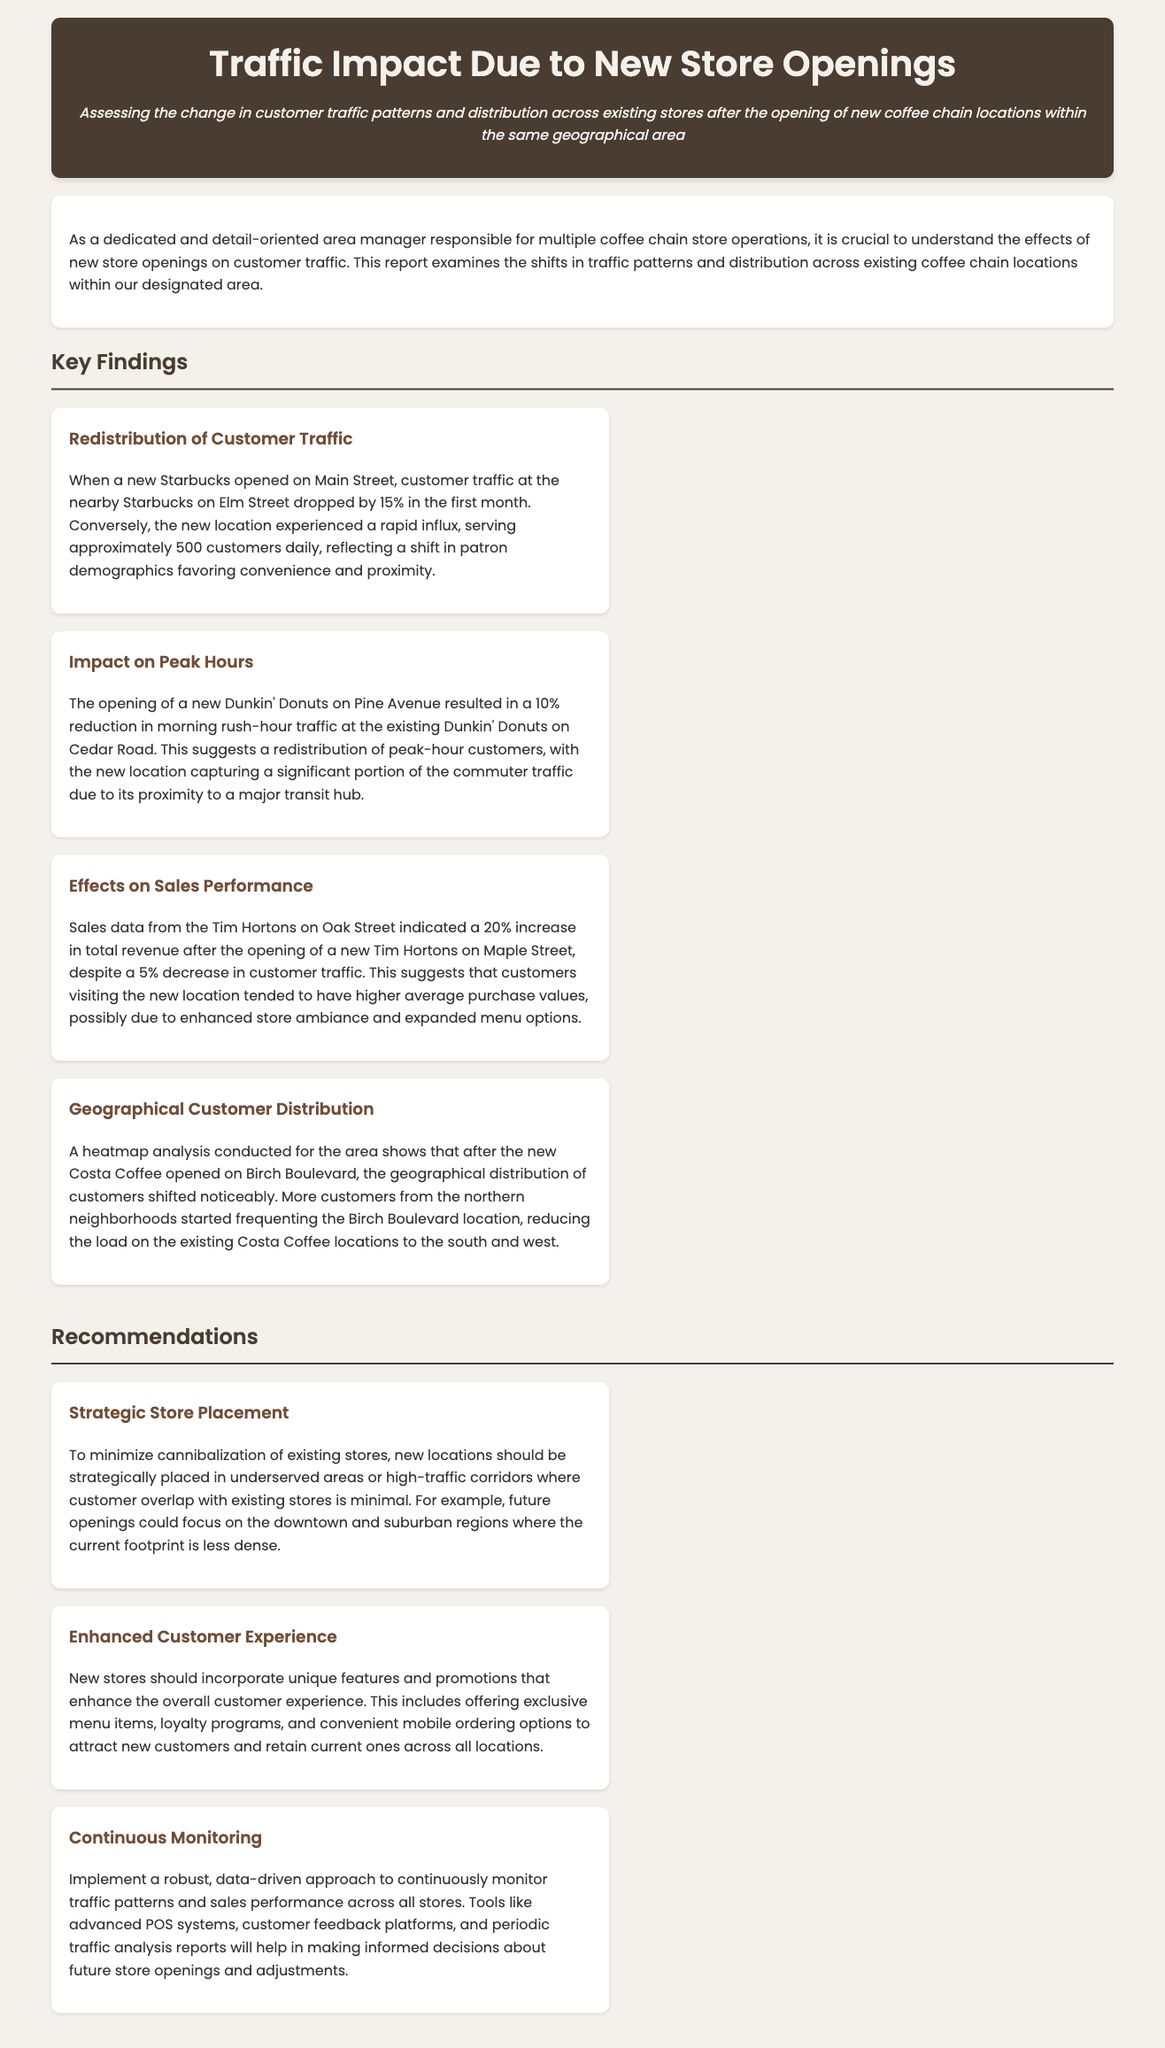What was the percentage drop in customer traffic at the Elm Street Starbucks? The document states that customer traffic at the nearby Starbucks on Elm Street dropped by 15% in the first month after the new store opened.
Answer: 15% How many customers did the new Starbucks serve daily? The report indicates that the new location experienced a rapid influx, serving approximately 500 customers daily.
Answer: 500 What percentage reduction in morning rush-hour traffic occurred at the Cedar Road Dunkin' Donuts? The document notes a 10% reduction in morning rush-hour traffic at the existing Dunkin' Donuts on Cedar Road due to the new location.
Answer: 10% What was the total revenue increase reported for the Tim Hortons on Oak Street after the new store opening? Sales data indicated a 20% increase in total revenue for the Tim Hortons on Oak Street after the new location opened.
Answer: 20% What area experienced a noticeable shift in geographical customer distribution after the new Costa Coffee opened? The document mentions that the Birch Boulevard location saw a significant increase in customers from the northern neighborhoods.
Answer: Birch Boulevard What is one recommended strategy to minimize cannibalization of existing stores? The report suggests that new locations should be strategically placed in underserved areas or high-traffic corridors with minimal customer overlap.
Answer: Strategic store placement What is advised for enhancing customer experience in new stores? The recommendations include incorporating unique features and promotions such as exclusive menu items and loyalty programs for new stores.
Answer: Enhanced customer experience What system is suggested for continuous monitoring of traffic patterns? The report recommends implementing advanced POS systems, customer feedback platforms, and periodic traffic analysis reports for identifying traffic patterns.
Answer: Robust, data-driven approach 